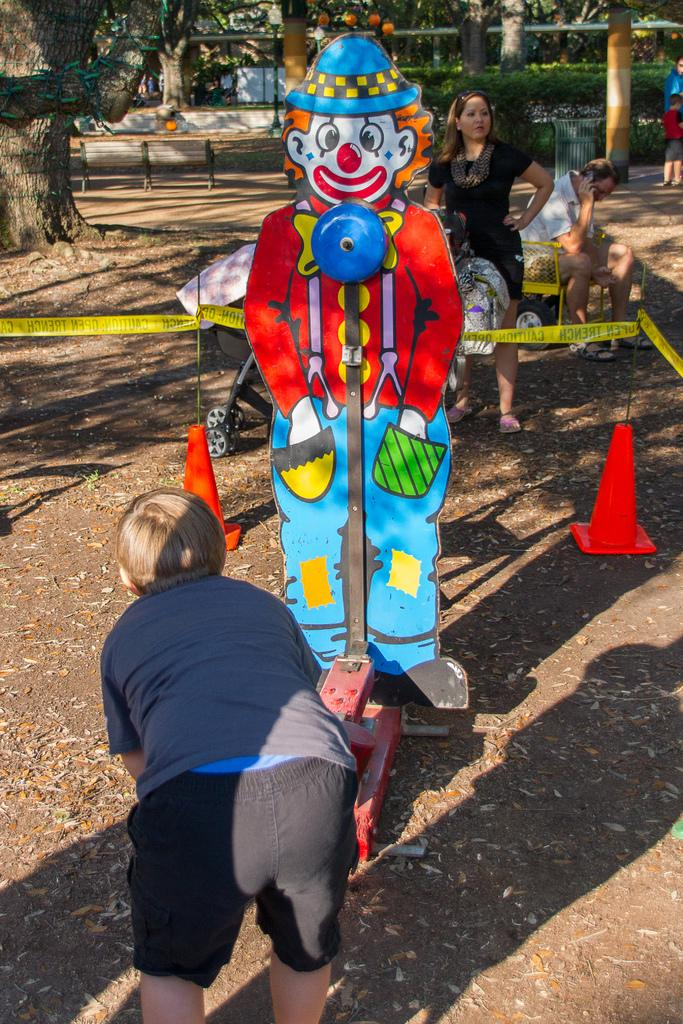What is the main subject of the image? There is a boy standing in the image. Where is the boy located? The boy is in a park. What other object can be seen in the image? There is a cartoon cardboard statue in the image. Can you describe the background of the image? There is a woman visible in the background of the image, and there are trees in the background as well. How much shade does the maid provide in the image? There is no maid present in the image, so it is not possible to determine the amount of shade provided. 